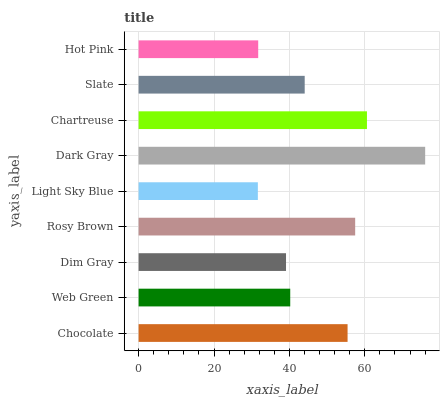Is Light Sky Blue the minimum?
Answer yes or no. Yes. Is Dark Gray the maximum?
Answer yes or no. Yes. Is Web Green the minimum?
Answer yes or no. No. Is Web Green the maximum?
Answer yes or no. No. Is Chocolate greater than Web Green?
Answer yes or no. Yes. Is Web Green less than Chocolate?
Answer yes or no. Yes. Is Web Green greater than Chocolate?
Answer yes or no. No. Is Chocolate less than Web Green?
Answer yes or no. No. Is Slate the high median?
Answer yes or no. Yes. Is Slate the low median?
Answer yes or no. Yes. Is Dim Gray the high median?
Answer yes or no. No. Is Light Sky Blue the low median?
Answer yes or no. No. 